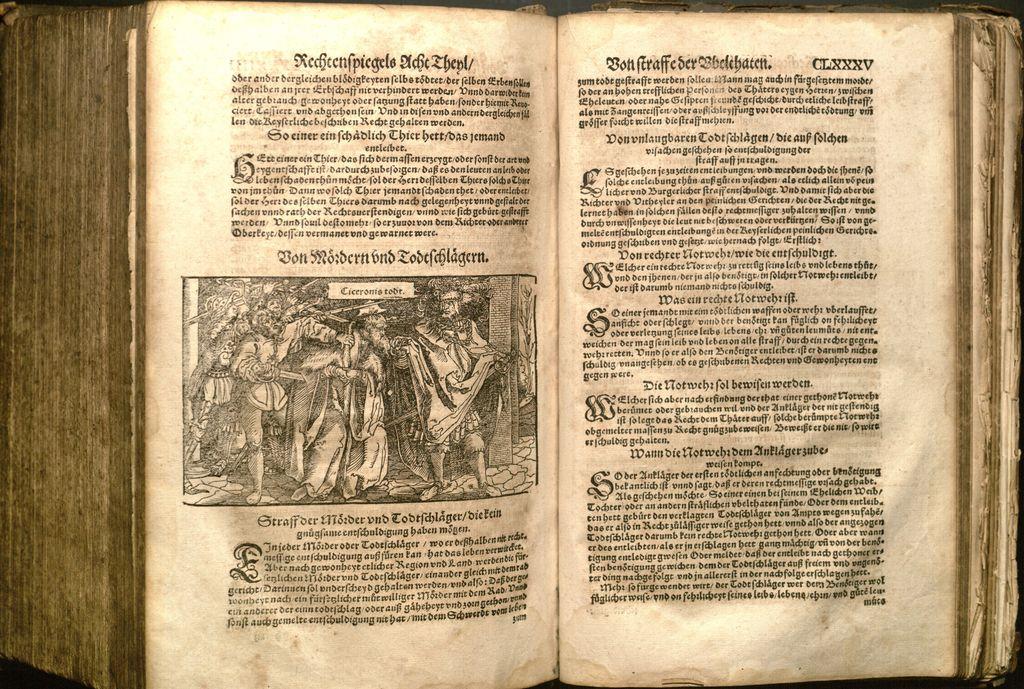Which page is the page on the right on?
Provide a short and direct response. Clxxxv. 